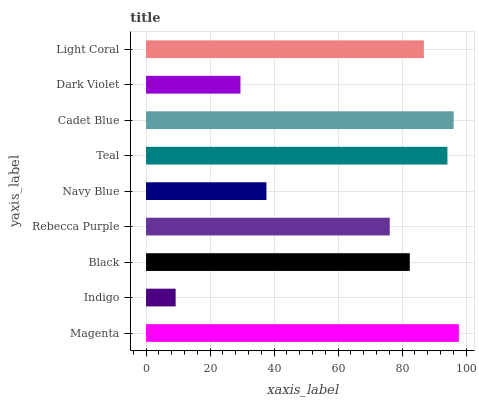Is Indigo the minimum?
Answer yes or no. Yes. Is Magenta the maximum?
Answer yes or no. Yes. Is Black the minimum?
Answer yes or no. No. Is Black the maximum?
Answer yes or no. No. Is Black greater than Indigo?
Answer yes or no. Yes. Is Indigo less than Black?
Answer yes or no. Yes. Is Indigo greater than Black?
Answer yes or no. No. Is Black less than Indigo?
Answer yes or no. No. Is Black the high median?
Answer yes or no. Yes. Is Black the low median?
Answer yes or no. Yes. Is Rebecca Purple the high median?
Answer yes or no. No. Is Light Coral the low median?
Answer yes or no. No. 